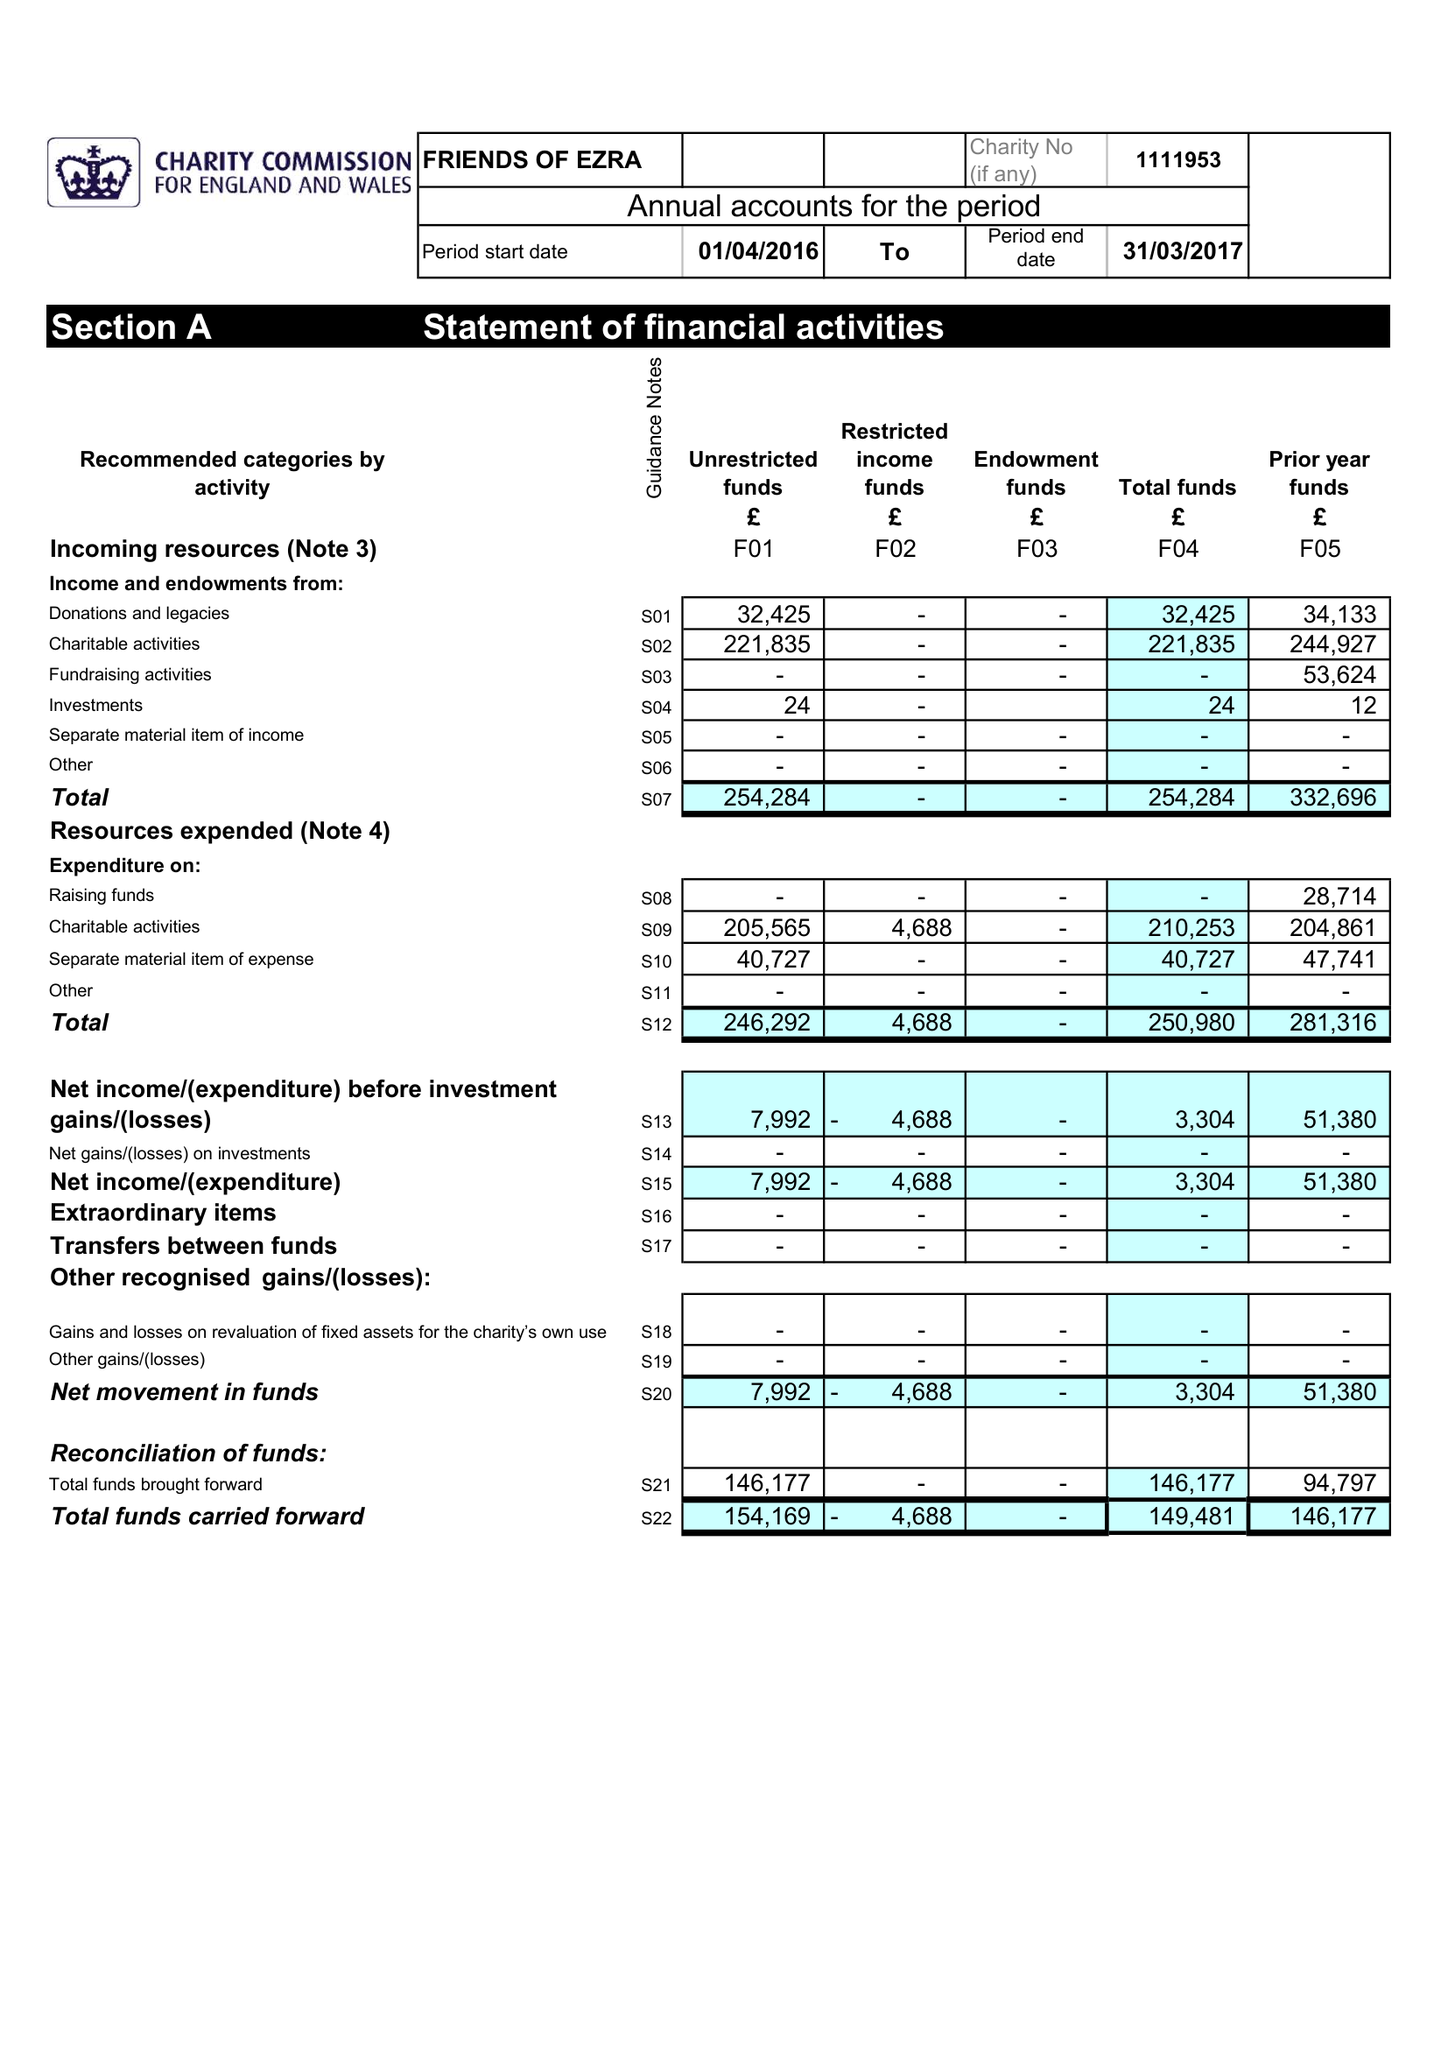What is the value for the report_date?
Answer the question using a single word or phrase. 2017-03-31 